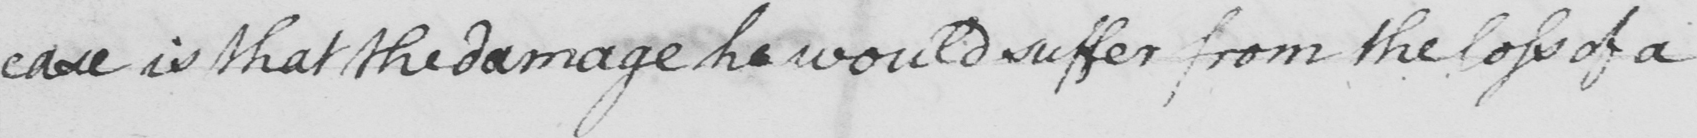What does this handwritten line say? case is that the damage he would suffer from the loss of a 